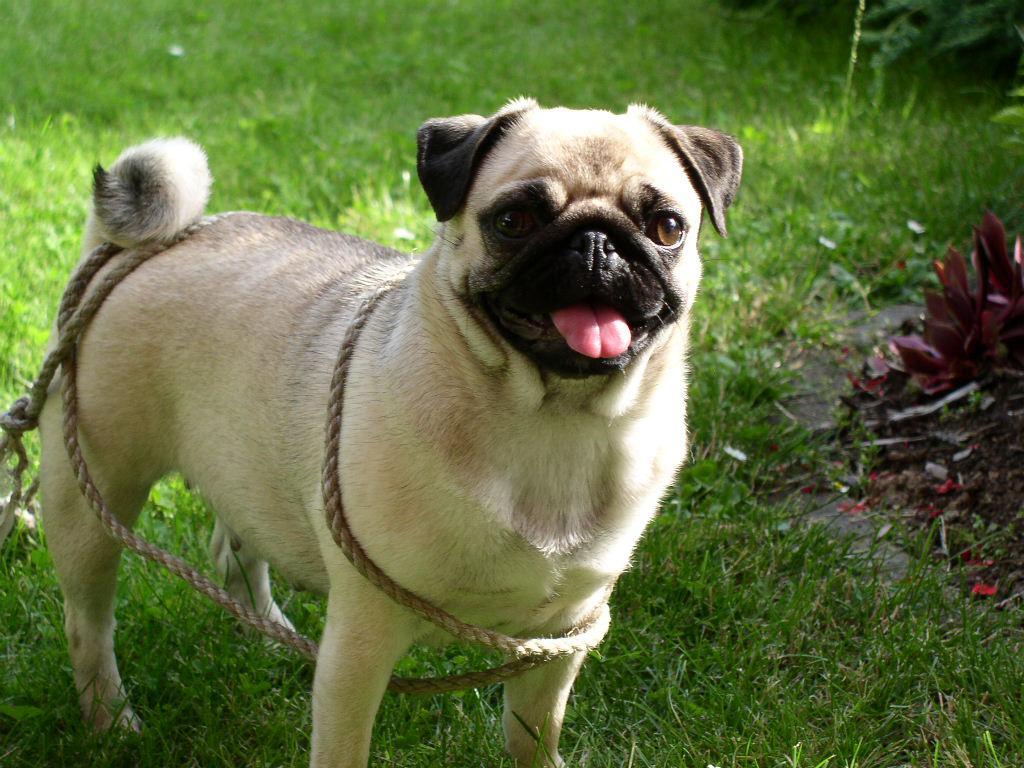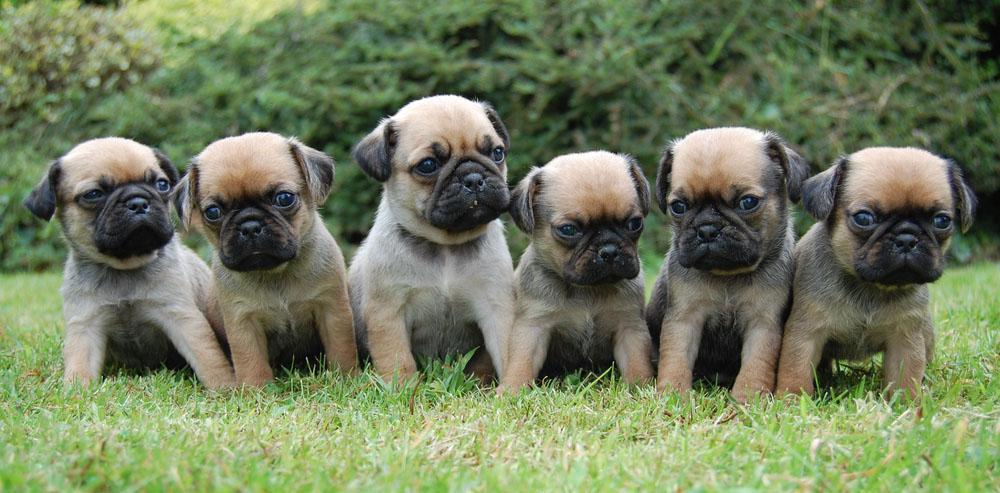The first image is the image on the left, the second image is the image on the right. For the images displayed, is the sentence "There is no more than one dog in the left image." factually correct? Answer yes or no. Yes. The first image is the image on the left, the second image is the image on the right. Given the left and right images, does the statement "An image shows one pug with a toy ball of some type." hold true? Answer yes or no. No. 